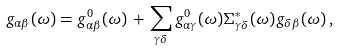Convert formula to latex. <formula><loc_0><loc_0><loc_500><loc_500>g _ { \alpha \beta } ( \omega ) = g ^ { 0 } _ { \alpha \beta } ( \omega ) \, + \, \sum _ { \gamma \delta } g ^ { 0 } _ { \alpha \gamma } ( \omega ) \Sigma ^ { * } _ { \gamma \delta } ( \omega ) g _ { \delta \beta } ( \omega ) \, ,</formula> 